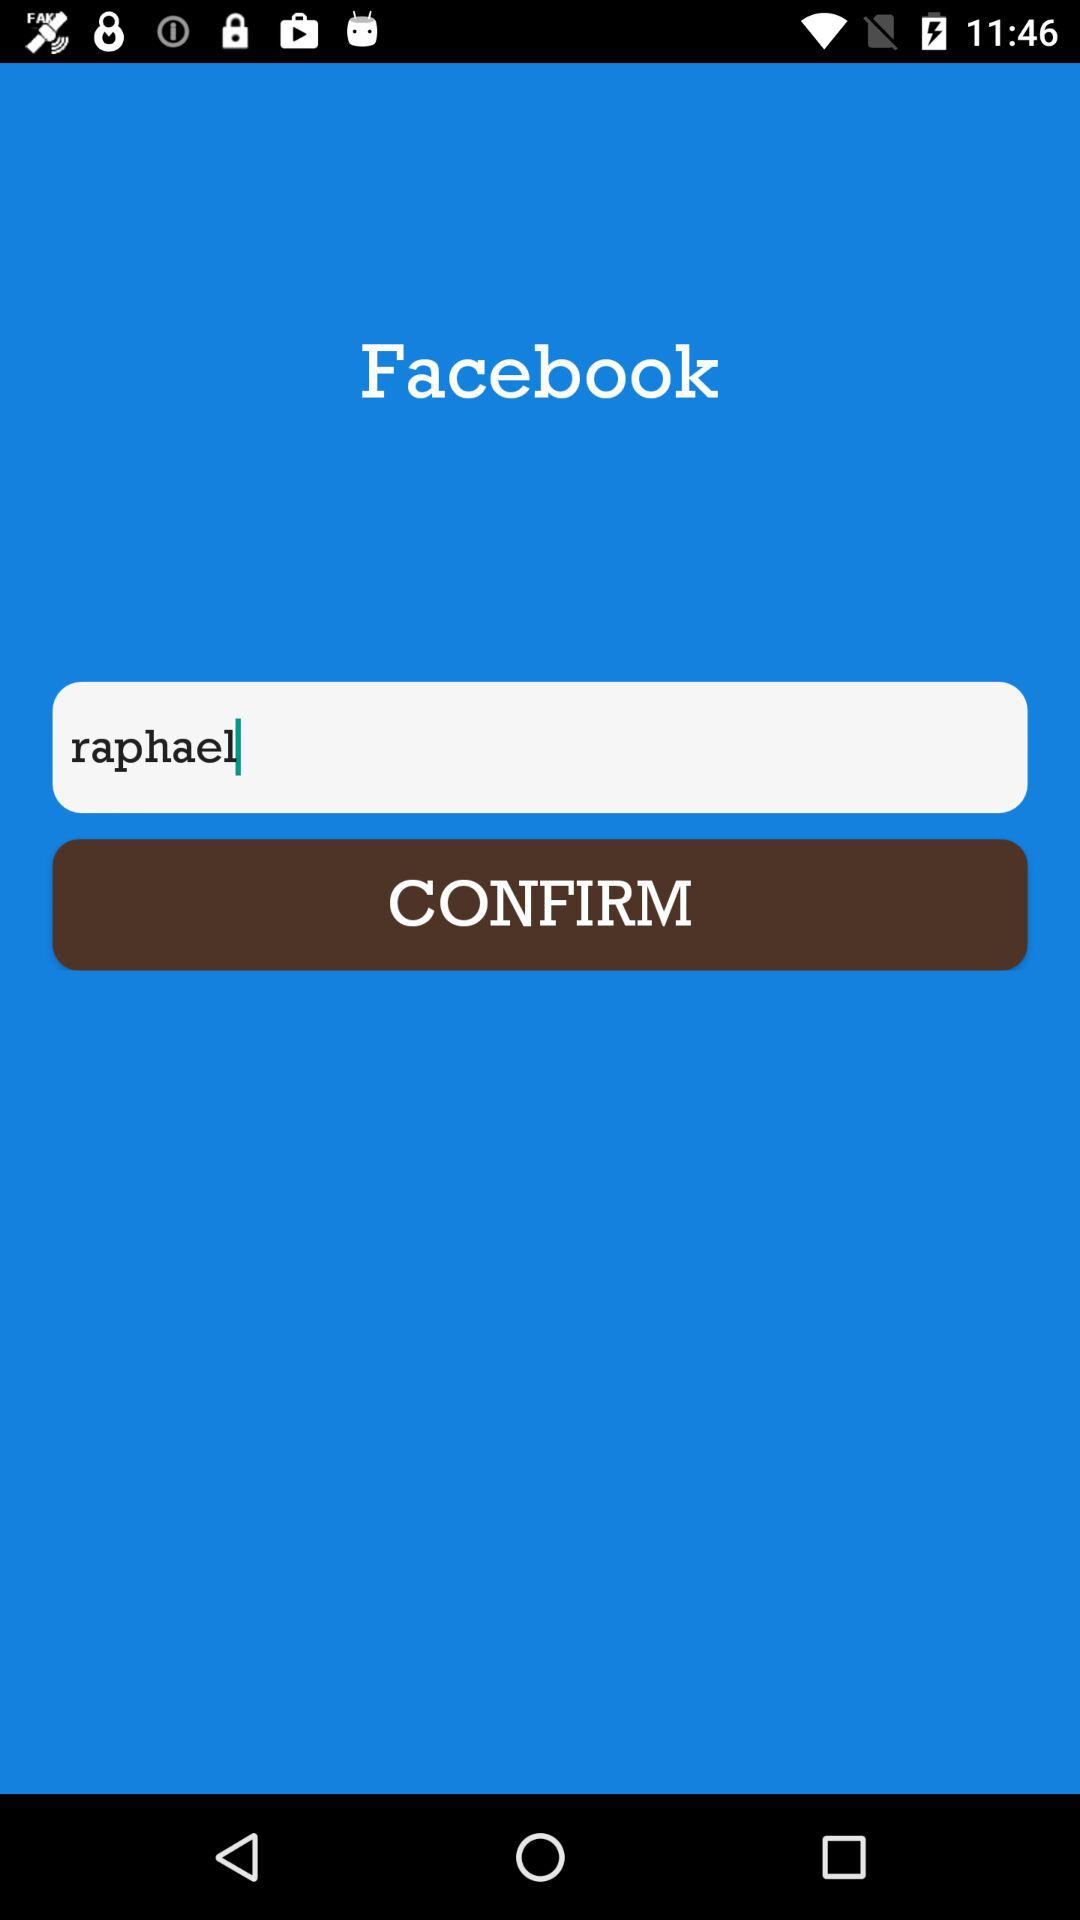What is the application name? The application name is "Facebook". 